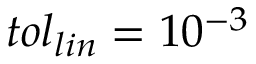<formula> <loc_0><loc_0><loc_500><loc_500>t o l _ { l i n } = 1 0 ^ { - 3 }</formula> 